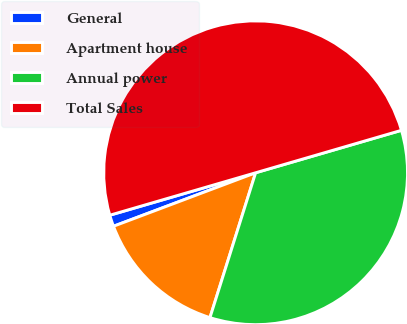Convert chart. <chart><loc_0><loc_0><loc_500><loc_500><pie_chart><fcel>General<fcel>Apartment house<fcel>Annual power<fcel>Total Sales<nl><fcel>1.22%<fcel>14.41%<fcel>34.37%<fcel>50.0%<nl></chart> 